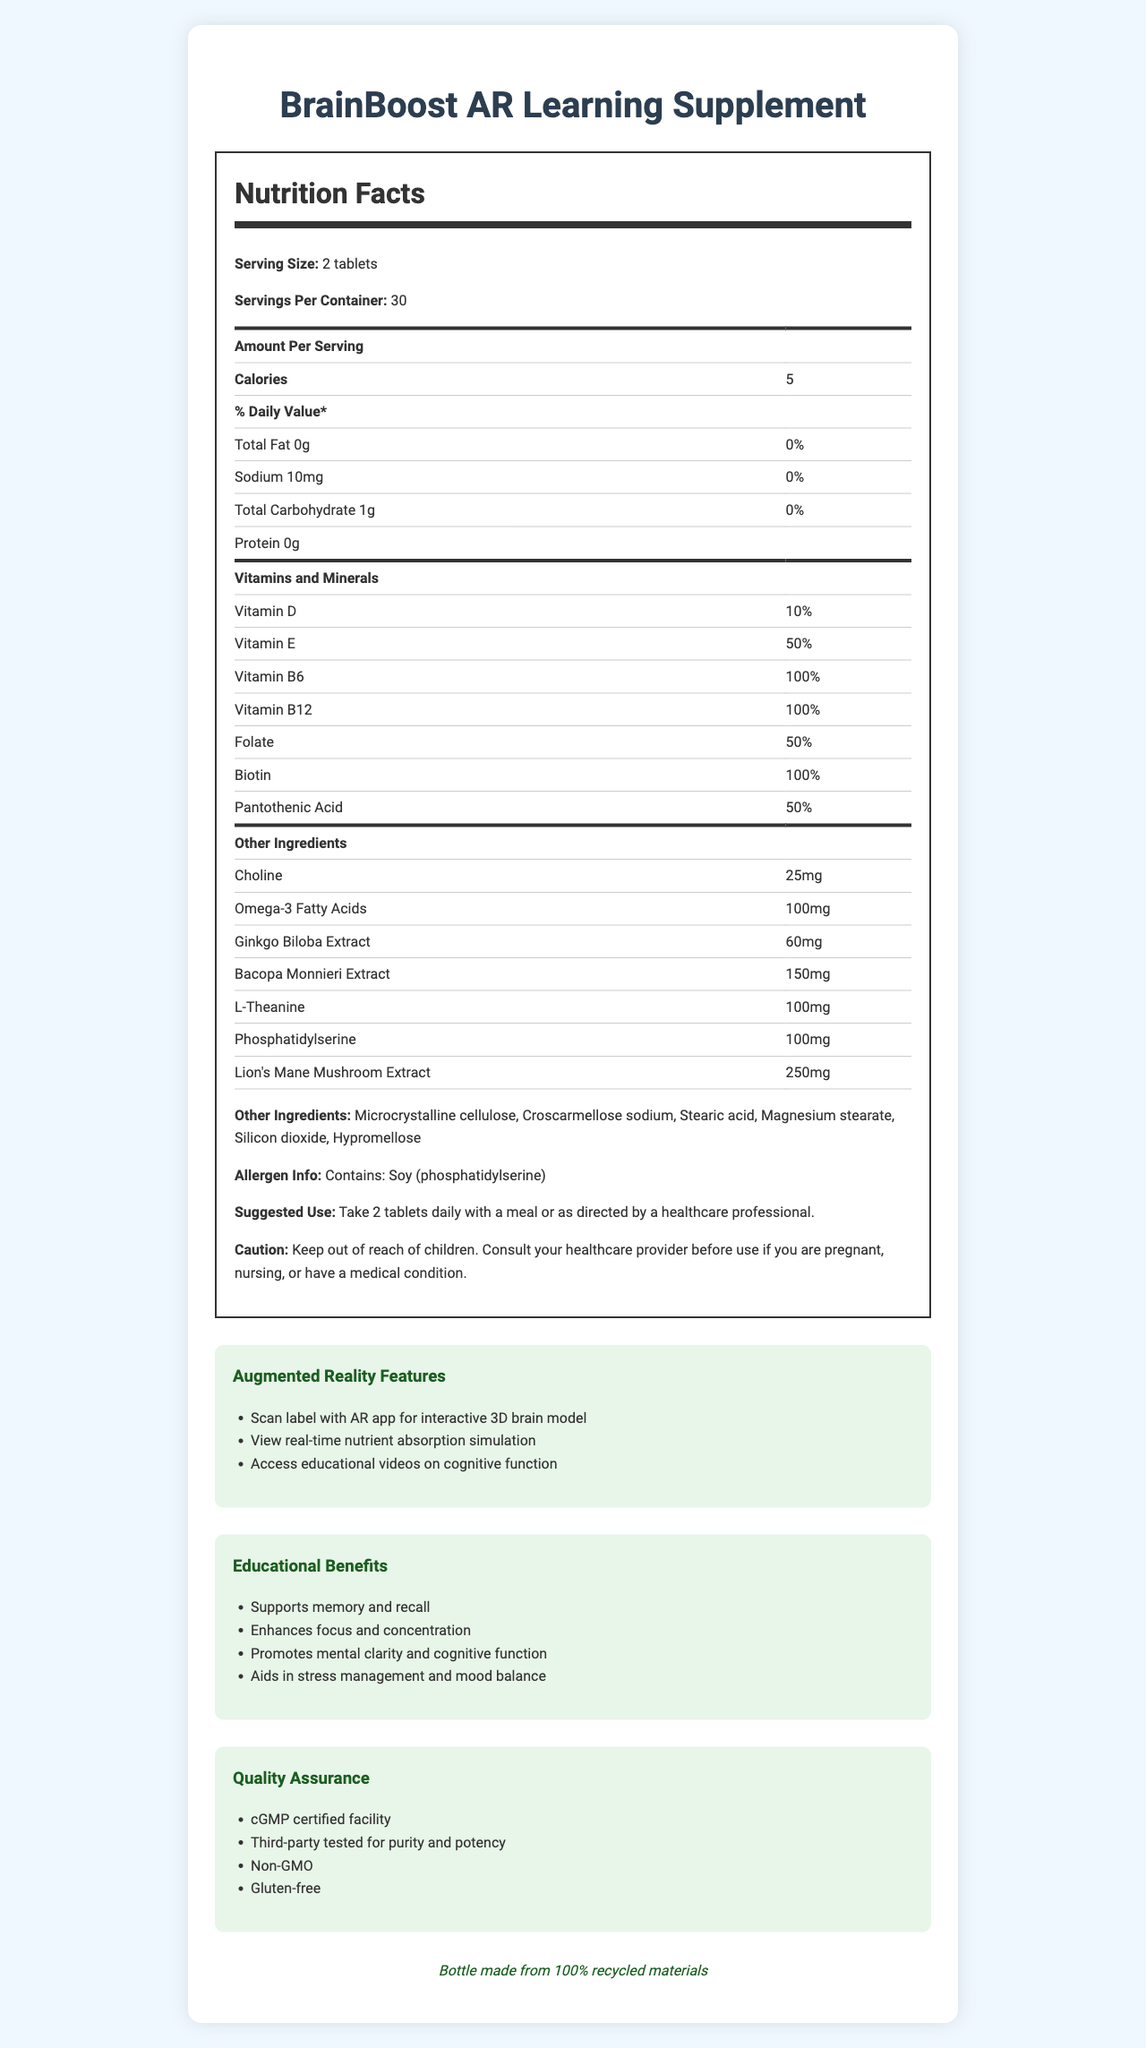what is the serving size of the BrainBoost AR Learning Supplement? The serving size is stated explicitly at the beginning of the Nutrition Facts as "Serving Size: 2 tablets".
Answer: 2 tablets how many calories are in one serving? The document lists the amount of calories per serving as 5 in the Nutrition Facts section.
Answer: 5 which vitamins are present at 100% Daily Value per serving? The Nutrition Facts specify that Vitamin B6, Vitamin B12, and Biotin are all present at 100% Daily Value.
Answer: Vitamin B6, Vitamin B12, Biotin what is the amount of Omega-3 Fatty Acids per serving? The amount of Omega-3 Fatty Acids per serving is listed in the section detailing additional ingredients as 100mg.
Answer: 100mg are there any allergens mentioned in the BrainBoost AR Learning Supplement? Under the Allergen Info section, it is stated that the product contains Soy (phosphatidylserine).
Answer: Yes, Soy (phosphatidylserine) how many servings are there per container? The Nutrition Facts state that there are 30 servings per container.
Answer: 30 what features does the augmented reality app offer? The Augmented Reality Features section lists these specific features.
Answer: Scan label with AR app for interactive 3D brain model, View real-time nutrient absorption simulation, Access educational videos on cognitive function which of the following is NOT an ingredient listed under "other ingredients"? A. Hypromellose B. Magnesium stearate C. Gelatin D. Silicon dioxide Gelatin is not listed under the "other ingredients" in the document.
Answer: C. Gelatin what percentage of the Daily Value of Vitamin E is provided per serving? A. 10% B. 50% C. 100% D. 25% The Nutrition Facts state that Vitamin E is at 50% of the Daily Value per serving.
Answer: B. 50% does the BrainBoost AR Learning Supplement contain gluten? The Quality Assurance section confirms that the product is Gluten-free.
Answer: No summarize the main features of the BrainBoost AR Learning Supplement outlined in the document. This summary captures the main features, including nutritional content, benefits, AR features, and quality assurances outlined in different sections of the document.
Answer: The BrainBoost AR Learning Supplement is designed to enhance focus and learning abilities. Each serving (2 tablets) contains various vitamins and nootropics, has specific education and cognitive benefits, and supports memory, focus, mental clarity, and stress management. The product uses augmented reality features for interactive educational purposes and is quality assured to be non-GMO, gluten-free, and made in a cGMP certified facility. It contains soy allergens and has a sustainability aspect with a 100% recycled materials bottle. what is the sustainability feature mentioned for the BrainBoost AR Learning Supplement? The sustainability aspect of the product is noted at the end of the document, stating that the bottle is made from 100% recycled materials.
Answer: Bottle made from 100% recycled materials is this product recommended for children? The document does not provide specific recommendations regarding the use of the product for children.
Answer: Cannot be determined which ingredient could help with stress management and mood balance? The Educational Benefits section lists stress management and mood balance as benefits, while the ingredients section lists L-Theanine, known for such effects.
Answer: L-Theanine 